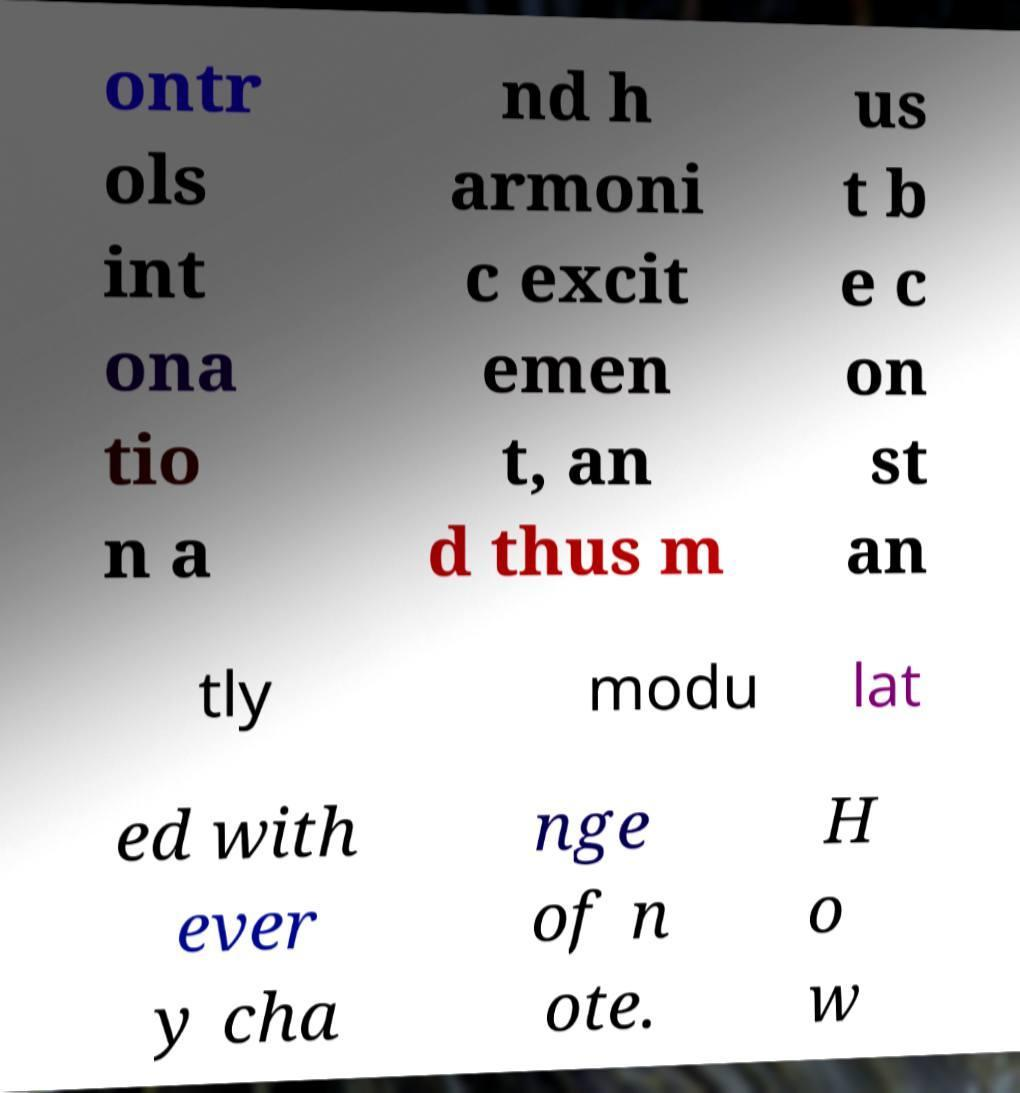Can you read and provide the text displayed in the image?This photo seems to have some interesting text. Can you extract and type it out for me? ontr ols int ona tio n a nd h armoni c excit emen t, an d thus m us t b e c on st an tly modu lat ed with ever y cha nge of n ote. H o w 